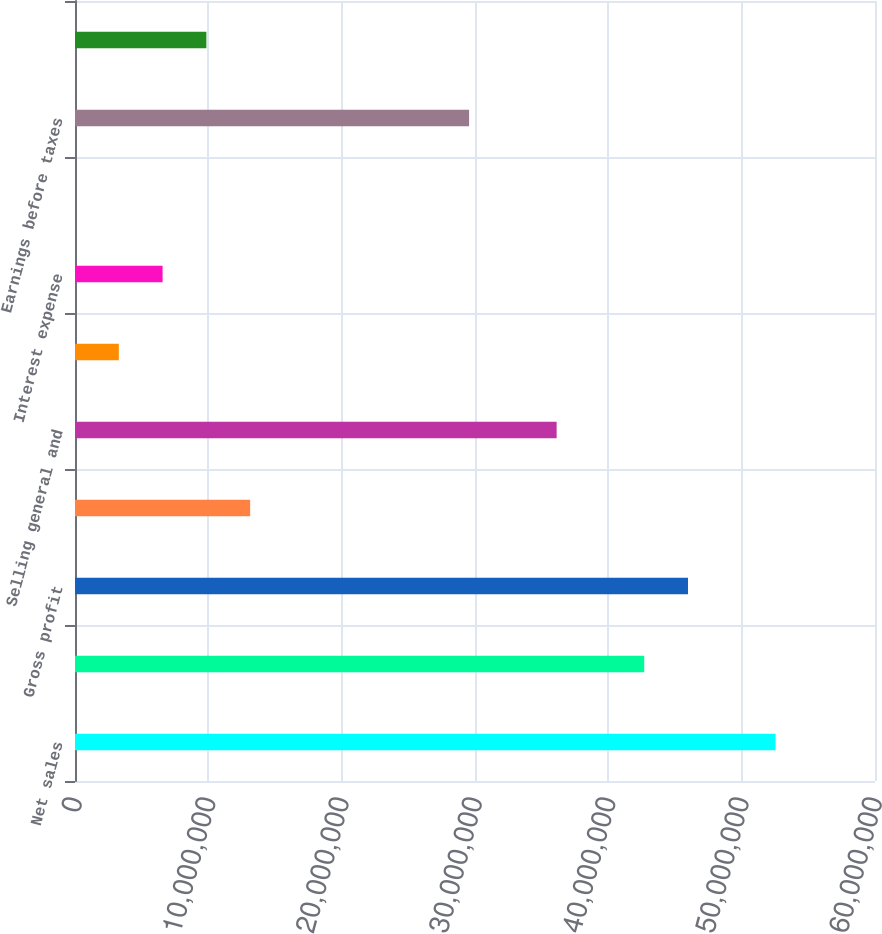<chart> <loc_0><loc_0><loc_500><loc_500><bar_chart><fcel>Net sales<fcel>Cost of sales<fcel>Gross profit<fcel>Research and development<fcel>Selling general and<fcel>Amortization<fcel>Interest expense<fcel>Other charges (income) net<fcel>Earnings before taxes<fcel>Provision for taxes ^(c)<nl><fcel>5.25416e+07<fcel>4.26905e+07<fcel>4.59742e+07<fcel>1.31372e+07<fcel>3.61231e+07<fcel>3.28608e+06<fcel>6.56978e+06<fcel>2380<fcel>2.95557e+07<fcel>9.85348e+06<nl></chart> 